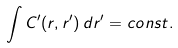<formula> <loc_0><loc_0><loc_500><loc_500>\int C ^ { \prime } ( r , r ^ { \prime } ) \, d r ^ { \prime } = c o n s t .</formula> 